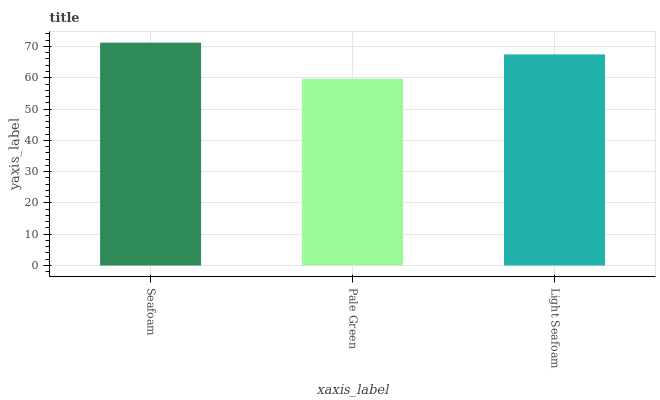Is Pale Green the minimum?
Answer yes or no. Yes. Is Seafoam the maximum?
Answer yes or no. Yes. Is Light Seafoam the minimum?
Answer yes or no. No. Is Light Seafoam the maximum?
Answer yes or no. No. Is Light Seafoam greater than Pale Green?
Answer yes or no. Yes. Is Pale Green less than Light Seafoam?
Answer yes or no. Yes. Is Pale Green greater than Light Seafoam?
Answer yes or no. No. Is Light Seafoam less than Pale Green?
Answer yes or no. No. Is Light Seafoam the high median?
Answer yes or no. Yes. Is Light Seafoam the low median?
Answer yes or no. Yes. Is Pale Green the high median?
Answer yes or no. No. Is Seafoam the low median?
Answer yes or no. No. 